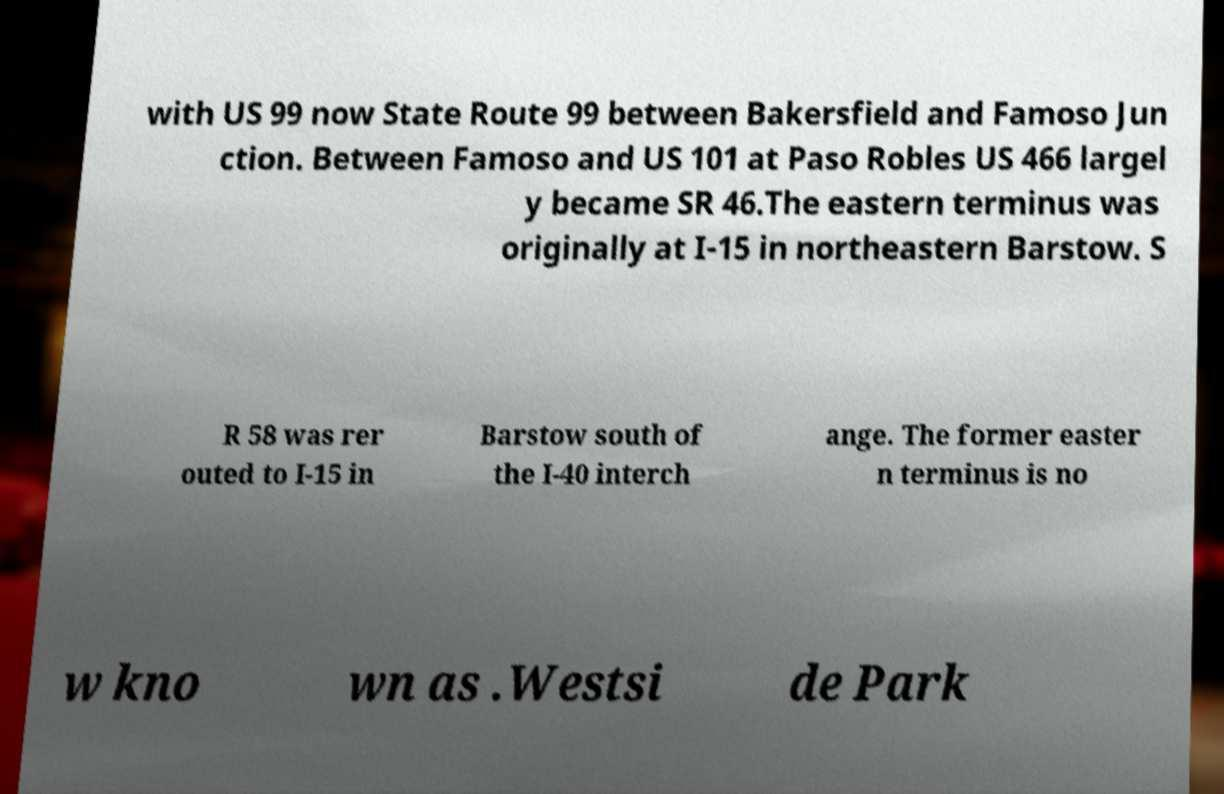For documentation purposes, I need the text within this image transcribed. Could you provide that? with US 99 now State Route 99 between Bakersfield and Famoso Jun ction. Between Famoso and US 101 at Paso Robles US 466 largel y became SR 46.The eastern terminus was originally at I-15 in northeastern Barstow. S R 58 was rer outed to I-15 in Barstow south of the I-40 interch ange. The former easter n terminus is no w kno wn as .Westsi de Park 